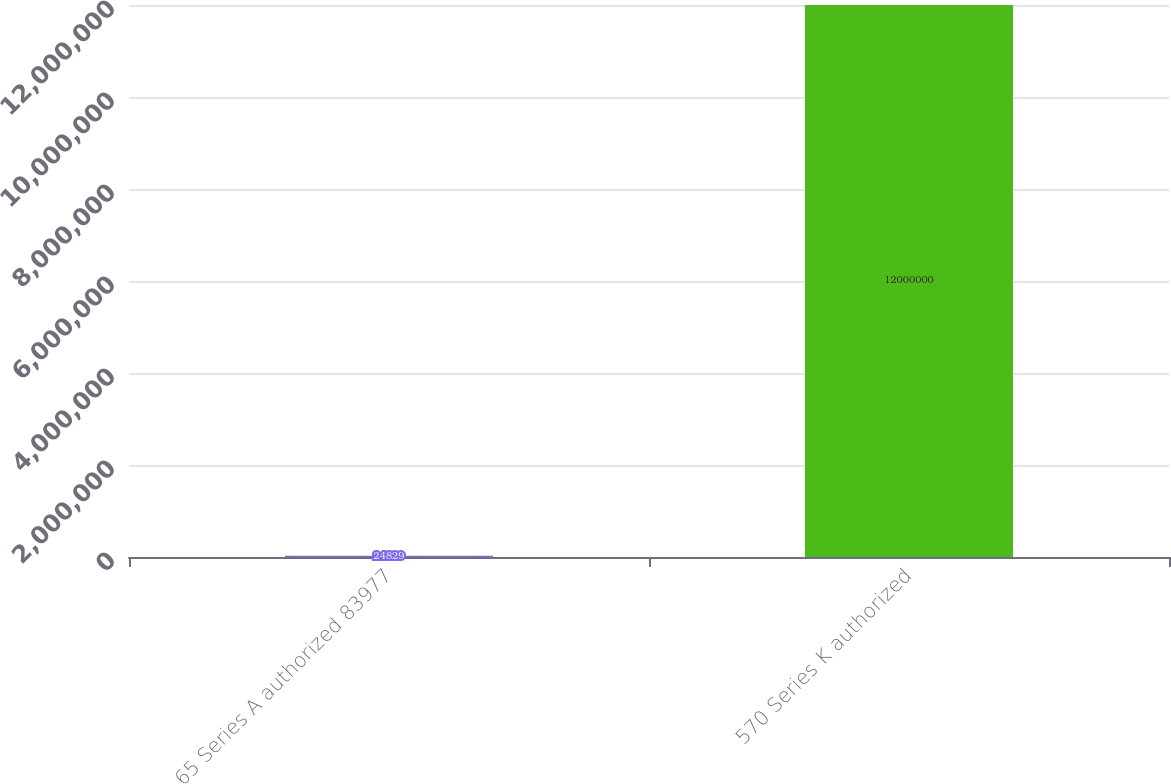Convert chart to OTSL. <chart><loc_0><loc_0><loc_500><loc_500><bar_chart><fcel>65 Series A authorized 83977<fcel>570 Series K authorized<nl><fcel>24829<fcel>1.2e+07<nl></chart> 